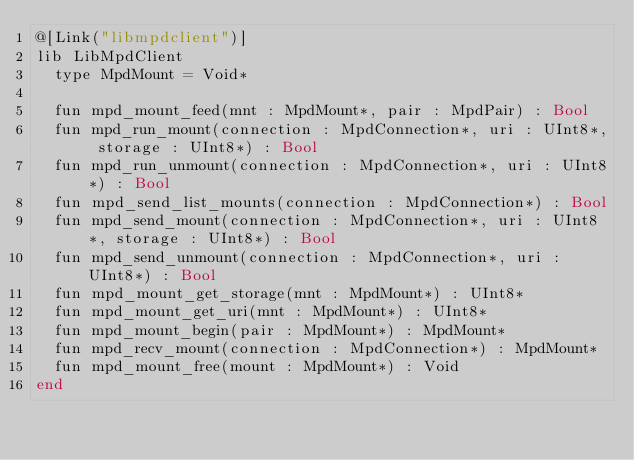<code> <loc_0><loc_0><loc_500><loc_500><_Crystal_>@[Link("libmpdclient")]
lib LibMpdClient
  type MpdMount = Void*

  fun mpd_mount_feed(mnt : MpdMount*, pair : MpdPair) : Bool
  fun mpd_run_mount(connection : MpdConnection*, uri : UInt8*, storage : UInt8*) : Bool
  fun mpd_run_unmount(connection : MpdConnection*, uri : UInt8*) : Bool
  fun mpd_send_list_mounts(connection : MpdConnection*) : Bool
  fun mpd_send_mount(connection : MpdConnection*, uri : UInt8*, storage : UInt8*) : Bool
  fun mpd_send_unmount(connection : MpdConnection*, uri : UInt8*) : Bool
  fun mpd_mount_get_storage(mnt : MpdMount*) : UInt8*
  fun mpd_mount_get_uri(mnt : MpdMount*) : UInt8*
  fun mpd_mount_begin(pair : MpdMount*) : MpdMount*
  fun mpd_recv_mount(connection : MpdConnection*) : MpdMount*
  fun mpd_mount_free(mount : MpdMount*) : Void
end
</code> 